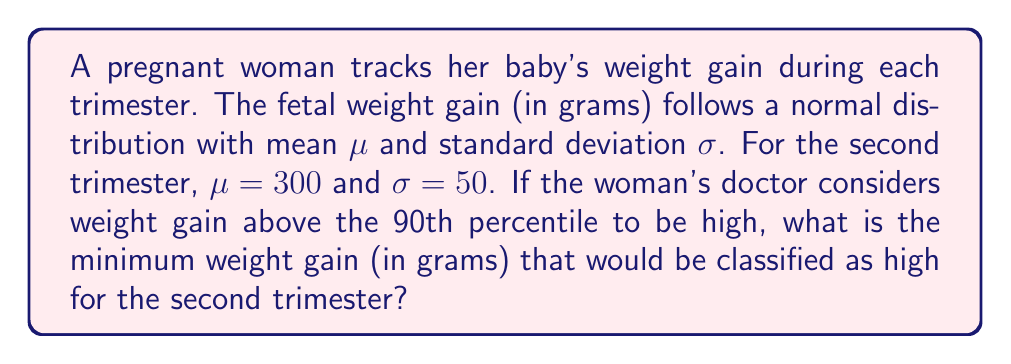Show me your answer to this math problem. To solve this problem, we need to use the properties of the normal distribution and the concept of z-scores. Let's break it down step-by-step:

1) We're looking for the 90th percentile, which means we need to find the z-score that corresponds to the 90th percentile of a standard normal distribution.

2) The z-score for the 90th percentile is approximately 1.28. We can find this using a standard normal distribution table or a calculator.

3) The formula for converting a z-score to an x-value in a normal distribution is:

   $$x = \mu + z\sigma$$

   Where:
   $x$ is the value we're looking for
   $\mu$ is the mean
   $z$ is the z-score
   $\sigma$ is the standard deviation

4) We know:
   $\mu = 300$
   $\sigma = 50$
   $z = 1.28$

5) Let's plug these values into our formula:

   $$x = 300 + 1.28(50)$$

6) Simplifying:

   $$x = 300 + 64 = 364$$

Therefore, any weight gain above 364 grams would be considered high (above the 90th percentile) for the second trimester.
Answer: 364 grams 